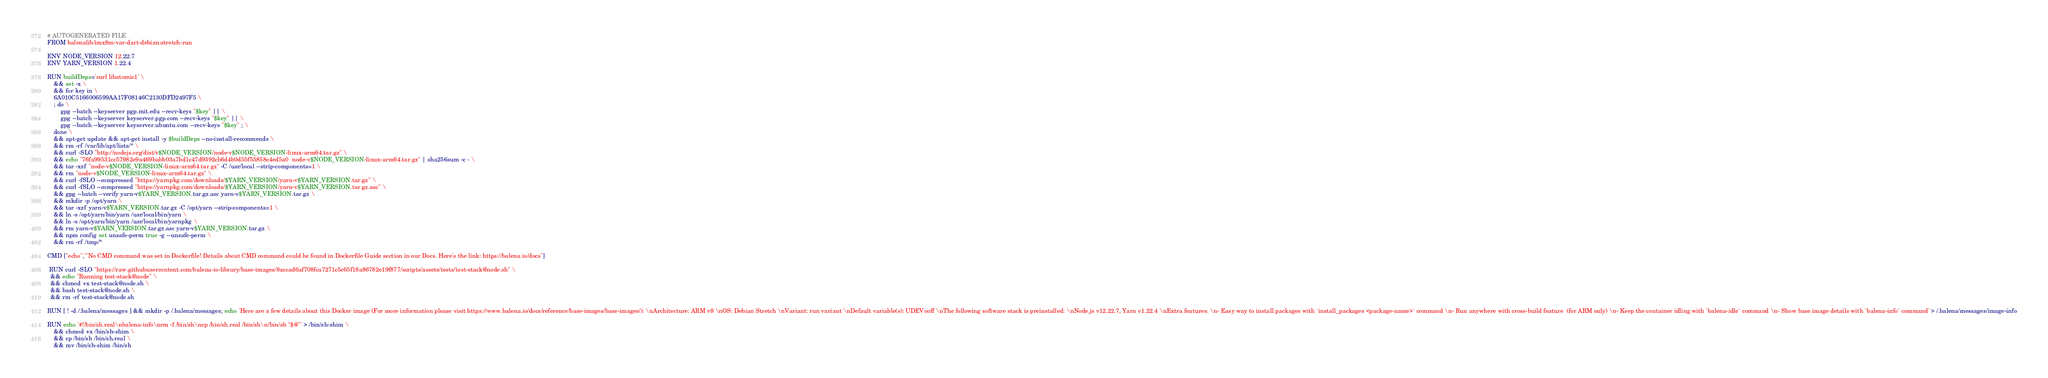Convert code to text. <code><loc_0><loc_0><loc_500><loc_500><_Dockerfile_># AUTOGENERATED FILE
FROM balenalib/imx8m-var-dart-debian:stretch-run

ENV NODE_VERSION 12.22.7
ENV YARN_VERSION 1.22.4

RUN buildDeps='curl libatomic1' \
	&& set -x \
	&& for key in \
	6A010C5166006599AA17F08146C2130DFD2497F5 \
	; do \
		gpg --batch --keyserver pgp.mit.edu --recv-keys "$key" || \
		gpg --batch --keyserver keyserver.pgp.com --recv-keys "$key" || \
		gpg --batch --keyserver keyserver.ubuntu.com --recv-keys "$key" ; \
	done \
	&& apt-get update && apt-get install -y $buildDeps --no-install-recommends \
	&& rm -rf /var/lib/apt/lists/* \
	&& curl -SLO "http://nodejs.org/dist/v$NODE_VERSION/node-v$NODE_VERSION-linux-arm64.tar.gz" \
	&& echo "76fa99531cc57982e9a469babb03a7bd1c47d9392cb6d4b0d55f55858c4ed5a0  node-v$NODE_VERSION-linux-arm64.tar.gz" | sha256sum -c - \
	&& tar -xzf "node-v$NODE_VERSION-linux-arm64.tar.gz" -C /usr/local --strip-components=1 \
	&& rm "node-v$NODE_VERSION-linux-arm64.tar.gz" \
	&& curl -fSLO --compressed "https://yarnpkg.com/downloads/$YARN_VERSION/yarn-v$YARN_VERSION.tar.gz" \
	&& curl -fSLO --compressed "https://yarnpkg.com/downloads/$YARN_VERSION/yarn-v$YARN_VERSION.tar.gz.asc" \
	&& gpg --batch --verify yarn-v$YARN_VERSION.tar.gz.asc yarn-v$YARN_VERSION.tar.gz \
	&& mkdir -p /opt/yarn \
	&& tar -xzf yarn-v$YARN_VERSION.tar.gz -C /opt/yarn --strip-components=1 \
	&& ln -s /opt/yarn/bin/yarn /usr/local/bin/yarn \
	&& ln -s /opt/yarn/bin/yarn /usr/local/bin/yarnpkg \
	&& rm yarn-v$YARN_VERSION.tar.gz.asc yarn-v$YARN_VERSION.tar.gz \
	&& npm config set unsafe-perm true -g --unsafe-perm \
	&& rm -rf /tmp/*

CMD ["echo","'No CMD command was set in Dockerfile! Details about CMD command could be found in Dockerfile Guide section in our Docs. Here's the link: https://balena.io/docs"]

 RUN curl -SLO "https://raw.githubusercontent.com/balena-io-library/base-images/8accad6af708fca7271c5c65f18a86782e19f877/scripts/assets/tests/test-stack@node.sh" \
  && echo "Running test-stack@node" \
  && chmod +x test-stack@node.sh \
  && bash test-stack@node.sh \
  && rm -rf test-stack@node.sh 

RUN [ ! -d /.balena/messages ] && mkdir -p /.balena/messages; echo 'Here are a few details about this Docker image (For more information please visit https://www.balena.io/docs/reference/base-images/base-images/): \nArchitecture: ARM v8 \nOS: Debian Stretch \nVariant: run variant \nDefault variable(s): UDEV=off \nThe following software stack is preinstalled: \nNode.js v12.22.7, Yarn v1.22.4 \nExtra features: \n- Easy way to install packages with `install_packages <package-name>` command \n- Run anywhere with cross-build feature  (for ARM only) \n- Keep the container idling with `balena-idle` command \n- Show base image details with `balena-info` command' > /.balena/messages/image-info

RUN echo '#!/bin/sh.real\nbalena-info\nrm -f /bin/sh\ncp /bin/sh.real /bin/sh\n/bin/sh "$@"' > /bin/sh-shim \
	&& chmod +x /bin/sh-shim \
	&& cp /bin/sh /bin/sh.real \
	&& mv /bin/sh-shim /bin/sh</code> 